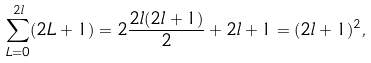Convert formula to latex. <formula><loc_0><loc_0><loc_500><loc_500>\sum _ { L = 0 } ^ { 2 l } ( 2 L + 1 ) = 2 \frac { 2 l ( 2 l + 1 ) } { 2 } + 2 l + 1 = ( 2 l + 1 ) ^ { 2 } ,</formula> 